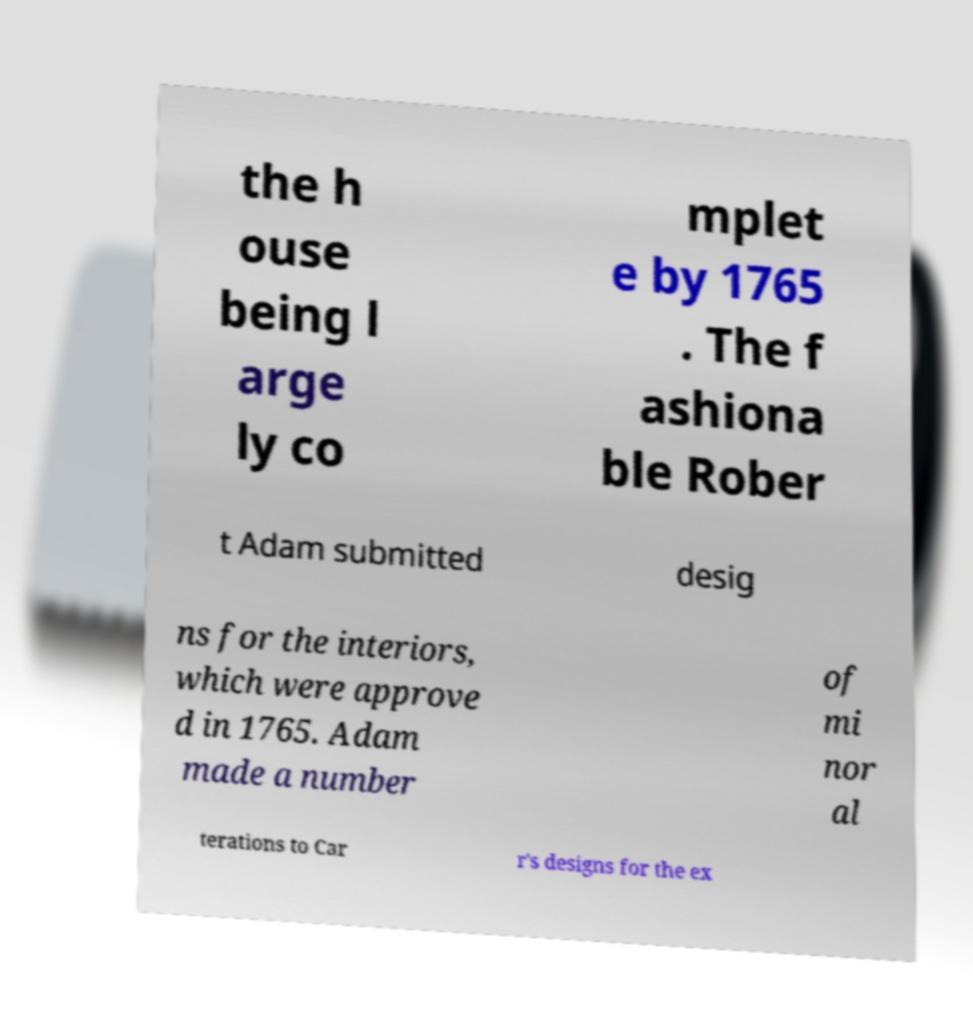I need the written content from this picture converted into text. Can you do that? the h ouse being l arge ly co mplet e by 1765 . The f ashiona ble Rober t Adam submitted desig ns for the interiors, which were approve d in 1765. Adam made a number of mi nor al terations to Car r's designs for the ex 